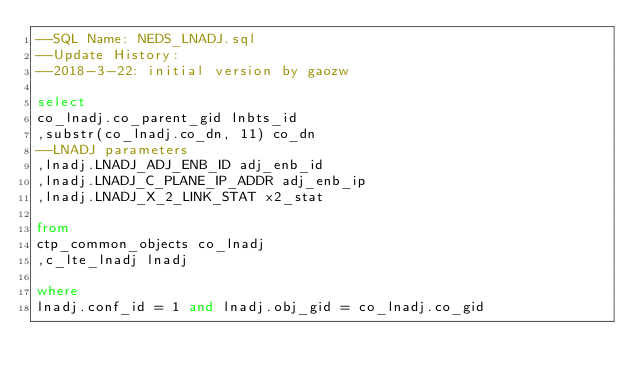<code> <loc_0><loc_0><loc_500><loc_500><_SQL_>--SQL Name: NEDS_LNADJ.sql
--Update History:
--2018-3-22: initial version by gaozw

select
co_lnadj.co_parent_gid lnbts_id
,substr(co_lnadj.co_dn, 11) co_dn
--LNADJ parameters
,lnadj.LNADJ_ADJ_ENB_ID adj_enb_id
,lnadj.LNADJ_C_PLANE_IP_ADDR adj_enb_ip
,lnadj.LNADJ_X_2_LINK_STAT x2_stat

from
ctp_common_objects co_lnadj
,c_lte_lnadj lnadj
 
where
lnadj.conf_id = 1 and lnadj.obj_gid = co_lnadj.co_gid
</code> 